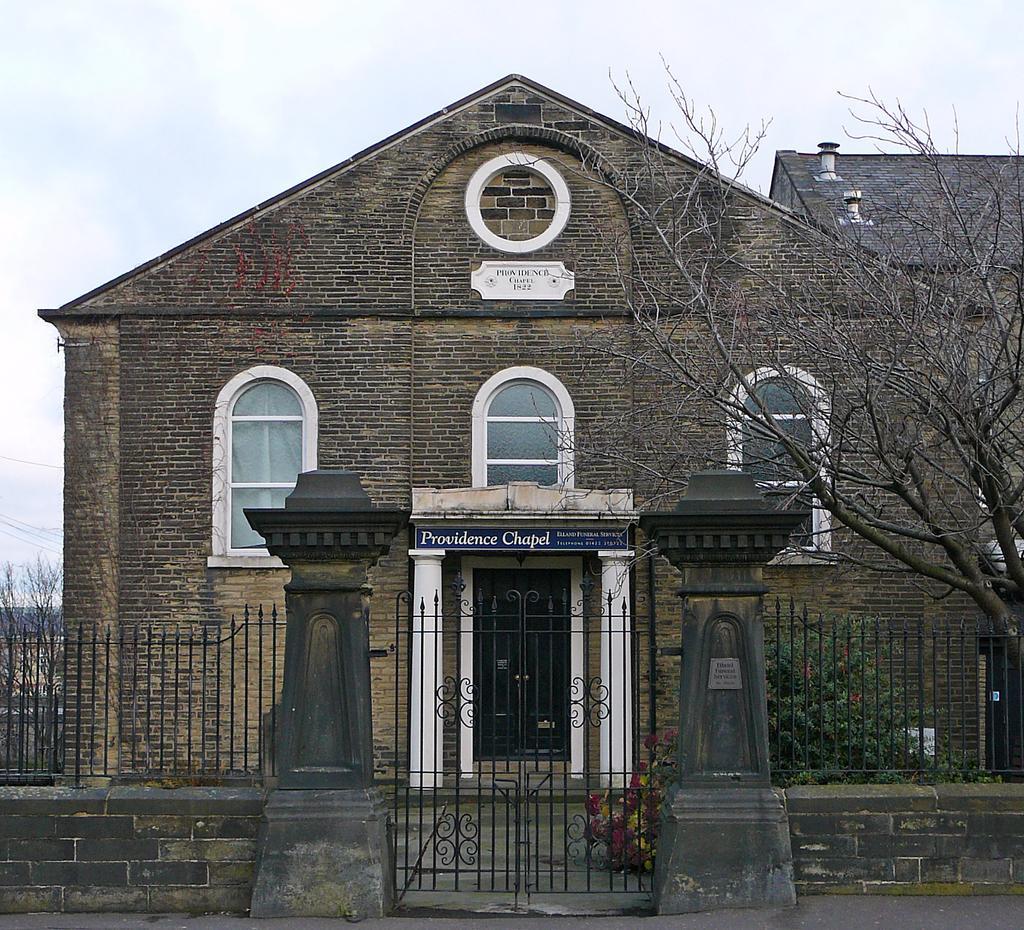In one or two sentences, can you explain what this image depicts? In this image we can see gate, fences on the wall, bare trees, building, windows, doors, name boards on the wall and clouds in the sky. 